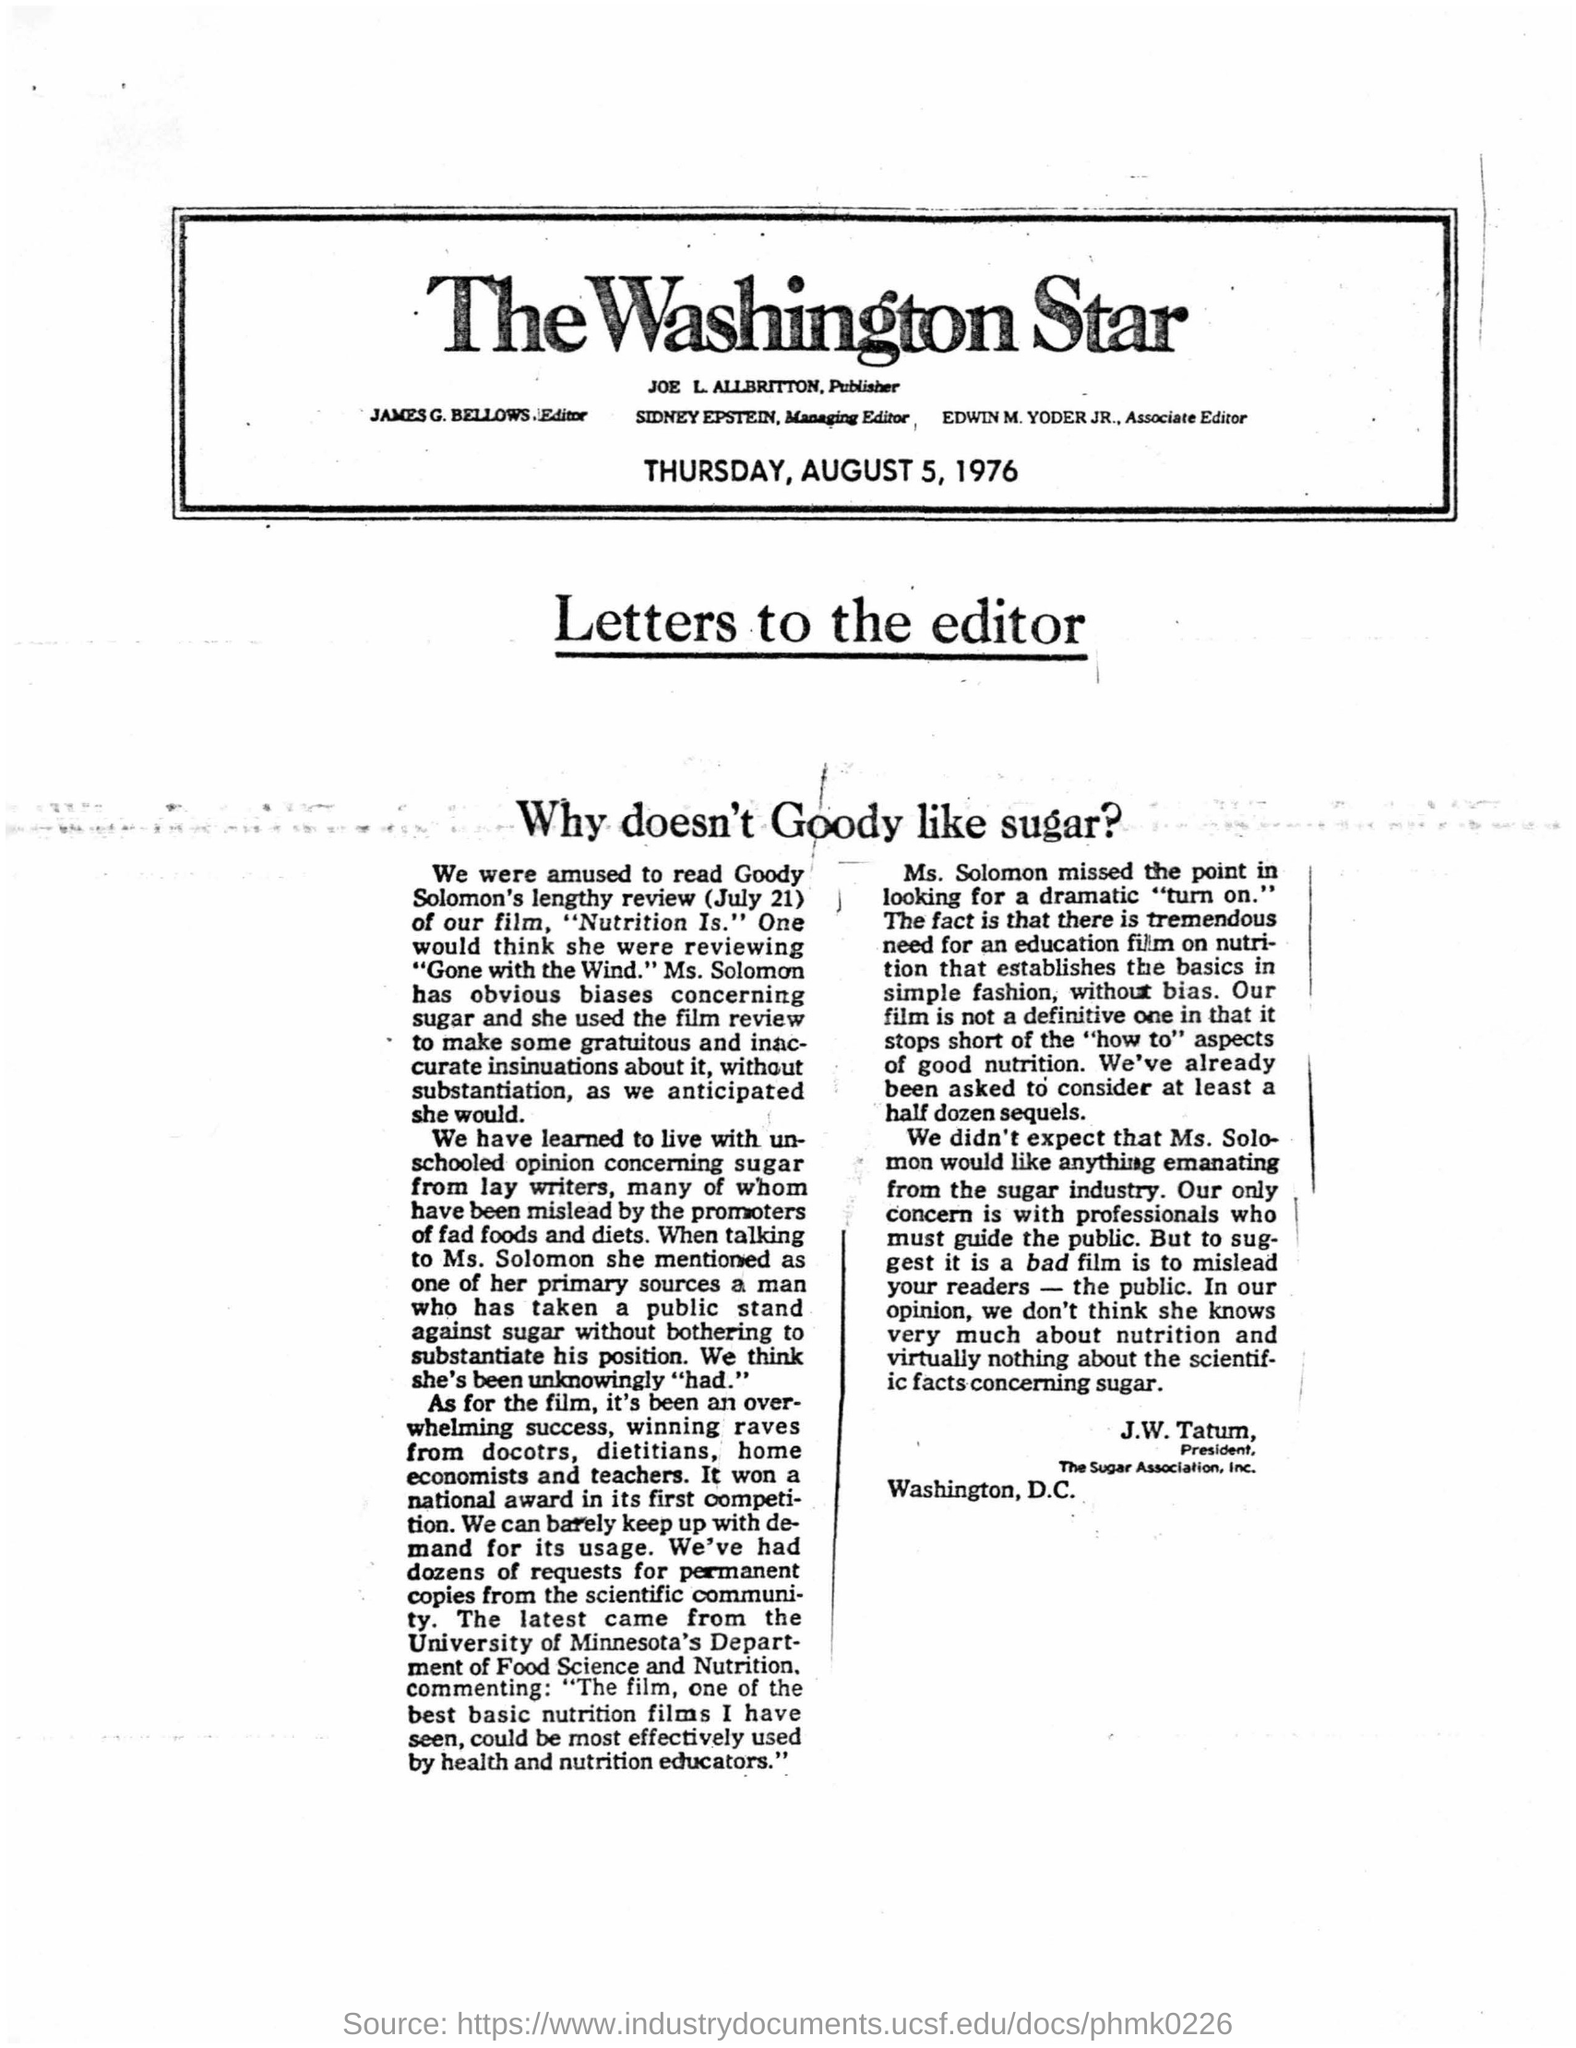Highlight a few significant elements in this photo. The President of the Sugar Association, Inc. is J.W. Tatum. The managing editor is Sidney Epstein. The article was printed on Thursday, August 5, 1976. James G. Bellows is the editor. 